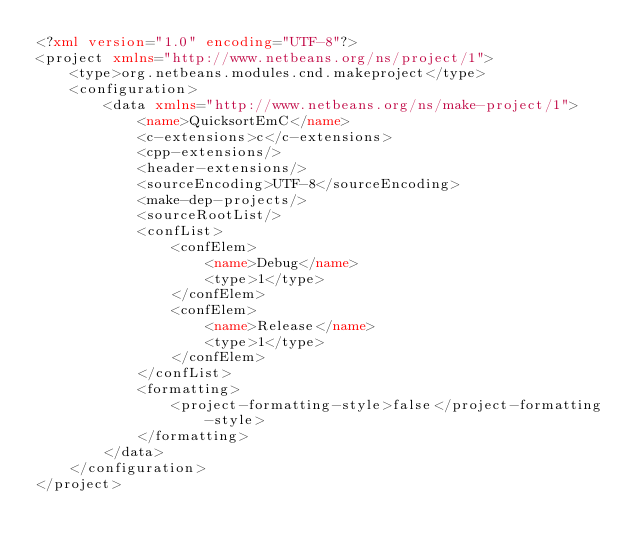<code> <loc_0><loc_0><loc_500><loc_500><_XML_><?xml version="1.0" encoding="UTF-8"?>
<project xmlns="http://www.netbeans.org/ns/project/1">
    <type>org.netbeans.modules.cnd.makeproject</type>
    <configuration>
        <data xmlns="http://www.netbeans.org/ns/make-project/1">
            <name>QuicksortEmC</name>
            <c-extensions>c</c-extensions>
            <cpp-extensions/>
            <header-extensions/>
            <sourceEncoding>UTF-8</sourceEncoding>
            <make-dep-projects/>
            <sourceRootList/>
            <confList>
                <confElem>
                    <name>Debug</name>
                    <type>1</type>
                </confElem>
                <confElem>
                    <name>Release</name>
                    <type>1</type>
                </confElem>
            </confList>
            <formatting>
                <project-formatting-style>false</project-formatting-style>
            </formatting>
        </data>
    </configuration>
</project>
</code> 